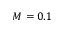Convert formula to latex. <formula><loc_0><loc_0><loc_500><loc_500>M = 0 . 1</formula> 